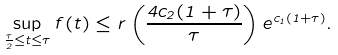Convert formula to latex. <formula><loc_0><loc_0><loc_500><loc_500>\sup _ { \frac { \tau } { 2 } \leq t \leq \tau } f ( t ) \leq r \left ( \frac { 4 c _ { 2 } ( 1 + \tau ) } { \tau } \right ) e ^ { c _ { 1 } ( 1 + \tau ) } .</formula> 